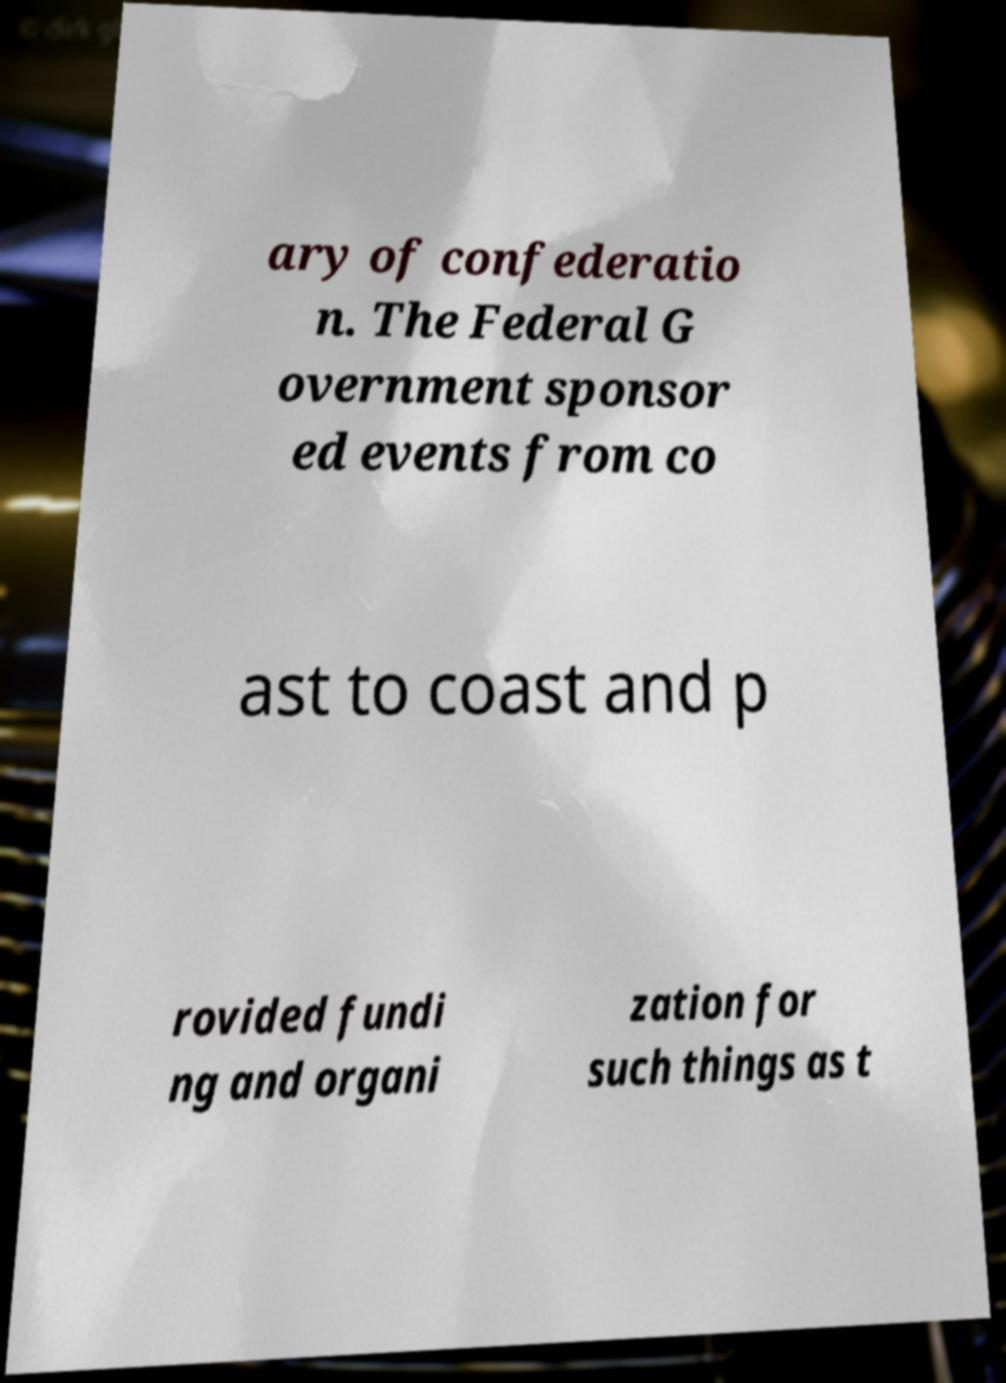There's text embedded in this image that I need extracted. Can you transcribe it verbatim? ary of confederatio n. The Federal G overnment sponsor ed events from co ast to coast and p rovided fundi ng and organi zation for such things as t 